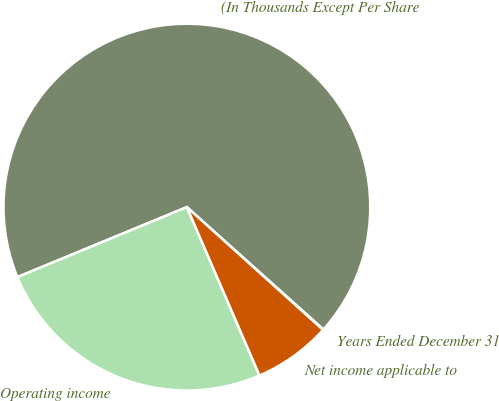Convert chart. <chart><loc_0><loc_0><loc_500><loc_500><pie_chart><fcel>Years Ended December 31<fcel>(In Thousands Except Per Share<fcel>Operating income<fcel>Net income applicable to<nl><fcel>0.06%<fcel>67.85%<fcel>25.25%<fcel>6.84%<nl></chart> 